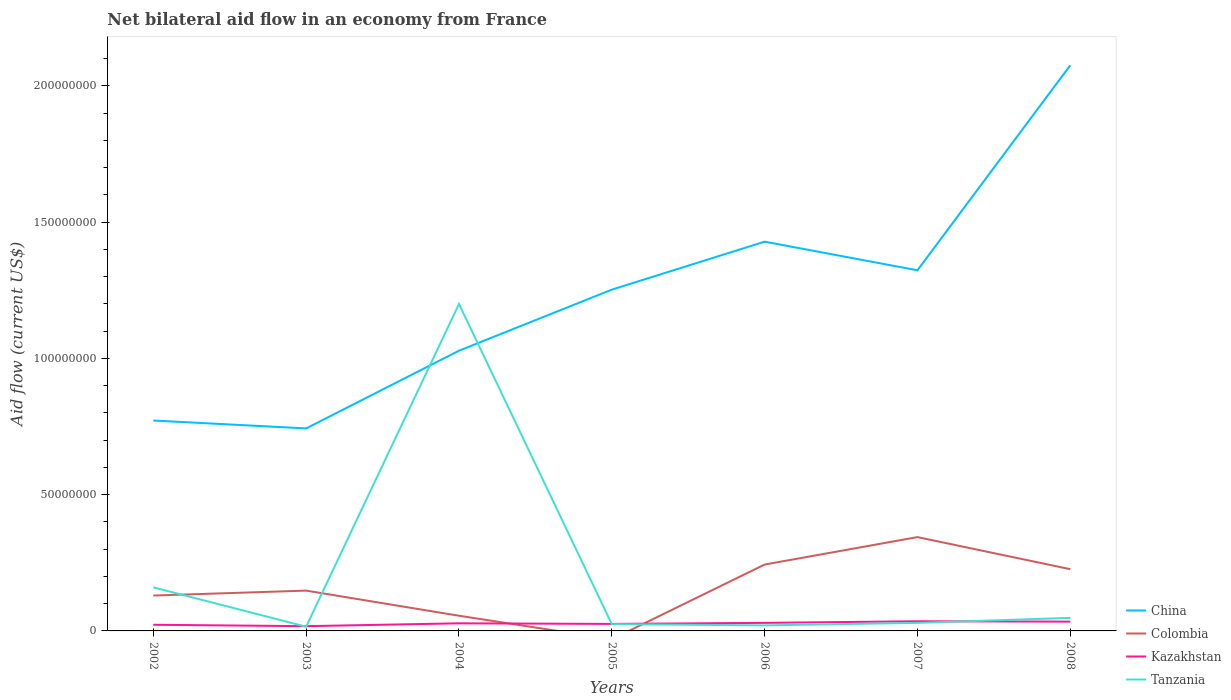How many different coloured lines are there?
Make the answer very short. 4. Does the line corresponding to Colombia intersect with the line corresponding to Tanzania?
Provide a succinct answer. Yes. Is the number of lines equal to the number of legend labels?
Your response must be concise. No. Across all years, what is the maximum net bilateral aid flow in Colombia?
Offer a very short reply. 0. What is the total net bilateral aid flow in Colombia in the graph?
Your response must be concise. 1.18e+07. What is the difference between the highest and the second highest net bilateral aid flow in Tanzania?
Make the answer very short. 1.18e+08. What is the difference between the highest and the lowest net bilateral aid flow in Tanzania?
Provide a short and direct response. 1. What is the title of the graph?
Provide a succinct answer. Net bilateral aid flow in an economy from France. Does "Guinea-Bissau" appear as one of the legend labels in the graph?
Give a very brief answer. No. What is the Aid flow (current US$) in China in 2002?
Make the answer very short. 7.72e+07. What is the Aid flow (current US$) of Colombia in 2002?
Your answer should be very brief. 1.30e+07. What is the Aid flow (current US$) of Kazakhstan in 2002?
Your answer should be very brief. 2.26e+06. What is the Aid flow (current US$) in Tanzania in 2002?
Give a very brief answer. 1.60e+07. What is the Aid flow (current US$) of China in 2003?
Ensure brevity in your answer.  7.43e+07. What is the Aid flow (current US$) in Colombia in 2003?
Provide a succinct answer. 1.48e+07. What is the Aid flow (current US$) in Kazakhstan in 2003?
Provide a short and direct response. 1.74e+06. What is the Aid flow (current US$) in Tanzania in 2003?
Your answer should be very brief. 1.55e+06. What is the Aid flow (current US$) of China in 2004?
Provide a short and direct response. 1.03e+08. What is the Aid flow (current US$) of Colombia in 2004?
Keep it short and to the point. 5.57e+06. What is the Aid flow (current US$) in Kazakhstan in 2004?
Keep it short and to the point. 2.79e+06. What is the Aid flow (current US$) in Tanzania in 2004?
Make the answer very short. 1.20e+08. What is the Aid flow (current US$) of China in 2005?
Provide a short and direct response. 1.25e+08. What is the Aid flow (current US$) of Colombia in 2005?
Keep it short and to the point. 0. What is the Aid flow (current US$) of Kazakhstan in 2005?
Your answer should be very brief. 2.57e+06. What is the Aid flow (current US$) of Tanzania in 2005?
Keep it short and to the point. 2.48e+06. What is the Aid flow (current US$) of China in 2006?
Offer a terse response. 1.43e+08. What is the Aid flow (current US$) of Colombia in 2006?
Ensure brevity in your answer.  2.44e+07. What is the Aid flow (current US$) of Kazakhstan in 2006?
Provide a short and direct response. 2.96e+06. What is the Aid flow (current US$) in Tanzania in 2006?
Provide a short and direct response. 2.03e+06. What is the Aid flow (current US$) in China in 2007?
Your answer should be very brief. 1.32e+08. What is the Aid flow (current US$) in Colombia in 2007?
Make the answer very short. 3.44e+07. What is the Aid flow (current US$) of Kazakhstan in 2007?
Your answer should be compact. 3.54e+06. What is the Aid flow (current US$) of Tanzania in 2007?
Offer a very short reply. 2.96e+06. What is the Aid flow (current US$) of China in 2008?
Provide a succinct answer. 2.08e+08. What is the Aid flow (current US$) in Colombia in 2008?
Keep it short and to the point. 2.26e+07. What is the Aid flow (current US$) in Kazakhstan in 2008?
Give a very brief answer. 3.41e+06. What is the Aid flow (current US$) of Tanzania in 2008?
Ensure brevity in your answer.  4.78e+06. Across all years, what is the maximum Aid flow (current US$) of China?
Provide a succinct answer. 2.08e+08. Across all years, what is the maximum Aid flow (current US$) in Colombia?
Ensure brevity in your answer.  3.44e+07. Across all years, what is the maximum Aid flow (current US$) of Kazakhstan?
Make the answer very short. 3.54e+06. Across all years, what is the maximum Aid flow (current US$) of Tanzania?
Provide a short and direct response. 1.20e+08. Across all years, what is the minimum Aid flow (current US$) in China?
Provide a short and direct response. 7.43e+07. Across all years, what is the minimum Aid flow (current US$) in Colombia?
Your response must be concise. 0. Across all years, what is the minimum Aid flow (current US$) of Kazakhstan?
Provide a short and direct response. 1.74e+06. Across all years, what is the minimum Aid flow (current US$) in Tanzania?
Offer a terse response. 1.55e+06. What is the total Aid flow (current US$) in China in the graph?
Keep it short and to the point. 8.62e+08. What is the total Aid flow (current US$) of Colombia in the graph?
Your answer should be very brief. 1.15e+08. What is the total Aid flow (current US$) of Kazakhstan in the graph?
Offer a terse response. 1.93e+07. What is the total Aid flow (current US$) in Tanzania in the graph?
Your answer should be compact. 1.50e+08. What is the difference between the Aid flow (current US$) in China in 2002 and that in 2003?
Provide a succinct answer. 2.90e+06. What is the difference between the Aid flow (current US$) in Colombia in 2002 and that in 2003?
Make the answer very short. -1.81e+06. What is the difference between the Aid flow (current US$) of Kazakhstan in 2002 and that in 2003?
Keep it short and to the point. 5.20e+05. What is the difference between the Aid flow (current US$) of Tanzania in 2002 and that in 2003?
Offer a very short reply. 1.44e+07. What is the difference between the Aid flow (current US$) of China in 2002 and that in 2004?
Give a very brief answer. -2.56e+07. What is the difference between the Aid flow (current US$) of Colombia in 2002 and that in 2004?
Provide a succinct answer. 7.41e+06. What is the difference between the Aid flow (current US$) of Kazakhstan in 2002 and that in 2004?
Ensure brevity in your answer.  -5.30e+05. What is the difference between the Aid flow (current US$) in Tanzania in 2002 and that in 2004?
Keep it short and to the point. -1.04e+08. What is the difference between the Aid flow (current US$) in China in 2002 and that in 2005?
Your answer should be compact. -4.80e+07. What is the difference between the Aid flow (current US$) in Kazakhstan in 2002 and that in 2005?
Make the answer very short. -3.10e+05. What is the difference between the Aid flow (current US$) of Tanzania in 2002 and that in 2005?
Provide a succinct answer. 1.35e+07. What is the difference between the Aid flow (current US$) of China in 2002 and that in 2006?
Keep it short and to the point. -6.56e+07. What is the difference between the Aid flow (current US$) of Colombia in 2002 and that in 2006?
Your response must be concise. -1.14e+07. What is the difference between the Aid flow (current US$) in Kazakhstan in 2002 and that in 2006?
Offer a very short reply. -7.00e+05. What is the difference between the Aid flow (current US$) in Tanzania in 2002 and that in 2006?
Make the answer very short. 1.40e+07. What is the difference between the Aid flow (current US$) in China in 2002 and that in 2007?
Your answer should be very brief. -5.51e+07. What is the difference between the Aid flow (current US$) of Colombia in 2002 and that in 2007?
Ensure brevity in your answer.  -2.14e+07. What is the difference between the Aid flow (current US$) of Kazakhstan in 2002 and that in 2007?
Provide a succinct answer. -1.28e+06. What is the difference between the Aid flow (current US$) of Tanzania in 2002 and that in 2007?
Offer a very short reply. 1.30e+07. What is the difference between the Aid flow (current US$) in China in 2002 and that in 2008?
Provide a succinct answer. -1.30e+08. What is the difference between the Aid flow (current US$) in Colombia in 2002 and that in 2008?
Make the answer very short. -9.67e+06. What is the difference between the Aid flow (current US$) of Kazakhstan in 2002 and that in 2008?
Provide a succinct answer. -1.15e+06. What is the difference between the Aid flow (current US$) in Tanzania in 2002 and that in 2008?
Offer a very short reply. 1.12e+07. What is the difference between the Aid flow (current US$) in China in 2003 and that in 2004?
Offer a very short reply. -2.85e+07. What is the difference between the Aid flow (current US$) in Colombia in 2003 and that in 2004?
Provide a short and direct response. 9.22e+06. What is the difference between the Aid flow (current US$) in Kazakhstan in 2003 and that in 2004?
Your response must be concise. -1.05e+06. What is the difference between the Aid flow (current US$) in Tanzania in 2003 and that in 2004?
Make the answer very short. -1.18e+08. What is the difference between the Aid flow (current US$) of China in 2003 and that in 2005?
Your response must be concise. -5.09e+07. What is the difference between the Aid flow (current US$) in Kazakhstan in 2003 and that in 2005?
Provide a succinct answer. -8.30e+05. What is the difference between the Aid flow (current US$) of Tanzania in 2003 and that in 2005?
Make the answer very short. -9.30e+05. What is the difference between the Aid flow (current US$) in China in 2003 and that in 2006?
Make the answer very short. -6.85e+07. What is the difference between the Aid flow (current US$) in Colombia in 2003 and that in 2006?
Your answer should be compact. -9.56e+06. What is the difference between the Aid flow (current US$) in Kazakhstan in 2003 and that in 2006?
Your answer should be compact. -1.22e+06. What is the difference between the Aid flow (current US$) of Tanzania in 2003 and that in 2006?
Make the answer very short. -4.80e+05. What is the difference between the Aid flow (current US$) of China in 2003 and that in 2007?
Make the answer very short. -5.80e+07. What is the difference between the Aid flow (current US$) in Colombia in 2003 and that in 2007?
Offer a very short reply. -1.96e+07. What is the difference between the Aid flow (current US$) of Kazakhstan in 2003 and that in 2007?
Ensure brevity in your answer.  -1.80e+06. What is the difference between the Aid flow (current US$) of Tanzania in 2003 and that in 2007?
Make the answer very short. -1.41e+06. What is the difference between the Aid flow (current US$) in China in 2003 and that in 2008?
Offer a very short reply. -1.33e+08. What is the difference between the Aid flow (current US$) of Colombia in 2003 and that in 2008?
Your response must be concise. -7.86e+06. What is the difference between the Aid flow (current US$) of Kazakhstan in 2003 and that in 2008?
Offer a terse response. -1.67e+06. What is the difference between the Aid flow (current US$) in Tanzania in 2003 and that in 2008?
Your answer should be very brief. -3.23e+06. What is the difference between the Aid flow (current US$) in China in 2004 and that in 2005?
Make the answer very short. -2.24e+07. What is the difference between the Aid flow (current US$) in Tanzania in 2004 and that in 2005?
Offer a very short reply. 1.17e+08. What is the difference between the Aid flow (current US$) in China in 2004 and that in 2006?
Give a very brief answer. -4.00e+07. What is the difference between the Aid flow (current US$) in Colombia in 2004 and that in 2006?
Ensure brevity in your answer.  -1.88e+07. What is the difference between the Aid flow (current US$) of Tanzania in 2004 and that in 2006?
Your response must be concise. 1.18e+08. What is the difference between the Aid flow (current US$) in China in 2004 and that in 2007?
Keep it short and to the point. -2.95e+07. What is the difference between the Aid flow (current US$) of Colombia in 2004 and that in 2007?
Provide a short and direct response. -2.88e+07. What is the difference between the Aid flow (current US$) in Kazakhstan in 2004 and that in 2007?
Keep it short and to the point. -7.50e+05. What is the difference between the Aid flow (current US$) of Tanzania in 2004 and that in 2007?
Offer a very short reply. 1.17e+08. What is the difference between the Aid flow (current US$) in China in 2004 and that in 2008?
Make the answer very short. -1.05e+08. What is the difference between the Aid flow (current US$) of Colombia in 2004 and that in 2008?
Keep it short and to the point. -1.71e+07. What is the difference between the Aid flow (current US$) in Kazakhstan in 2004 and that in 2008?
Your answer should be very brief. -6.20e+05. What is the difference between the Aid flow (current US$) of Tanzania in 2004 and that in 2008?
Give a very brief answer. 1.15e+08. What is the difference between the Aid flow (current US$) of China in 2005 and that in 2006?
Your answer should be very brief. -1.76e+07. What is the difference between the Aid flow (current US$) in Kazakhstan in 2005 and that in 2006?
Give a very brief answer. -3.90e+05. What is the difference between the Aid flow (current US$) of China in 2005 and that in 2007?
Offer a terse response. -7.10e+06. What is the difference between the Aid flow (current US$) of Kazakhstan in 2005 and that in 2007?
Provide a short and direct response. -9.70e+05. What is the difference between the Aid flow (current US$) in Tanzania in 2005 and that in 2007?
Your answer should be very brief. -4.80e+05. What is the difference between the Aid flow (current US$) in China in 2005 and that in 2008?
Offer a very short reply. -8.23e+07. What is the difference between the Aid flow (current US$) in Kazakhstan in 2005 and that in 2008?
Your response must be concise. -8.40e+05. What is the difference between the Aid flow (current US$) of Tanzania in 2005 and that in 2008?
Your answer should be very brief. -2.30e+06. What is the difference between the Aid flow (current US$) of China in 2006 and that in 2007?
Offer a terse response. 1.05e+07. What is the difference between the Aid flow (current US$) of Colombia in 2006 and that in 2007?
Make the answer very short. -1.01e+07. What is the difference between the Aid flow (current US$) of Kazakhstan in 2006 and that in 2007?
Your answer should be very brief. -5.80e+05. What is the difference between the Aid flow (current US$) of Tanzania in 2006 and that in 2007?
Your answer should be very brief. -9.30e+05. What is the difference between the Aid flow (current US$) of China in 2006 and that in 2008?
Your answer should be compact. -6.47e+07. What is the difference between the Aid flow (current US$) of Colombia in 2006 and that in 2008?
Ensure brevity in your answer.  1.70e+06. What is the difference between the Aid flow (current US$) in Kazakhstan in 2006 and that in 2008?
Your response must be concise. -4.50e+05. What is the difference between the Aid flow (current US$) of Tanzania in 2006 and that in 2008?
Your answer should be compact. -2.75e+06. What is the difference between the Aid flow (current US$) in China in 2007 and that in 2008?
Keep it short and to the point. -7.52e+07. What is the difference between the Aid flow (current US$) in Colombia in 2007 and that in 2008?
Offer a terse response. 1.18e+07. What is the difference between the Aid flow (current US$) of Kazakhstan in 2007 and that in 2008?
Offer a terse response. 1.30e+05. What is the difference between the Aid flow (current US$) in Tanzania in 2007 and that in 2008?
Provide a short and direct response. -1.82e+06. What is the difference between the Aid flow (current US$) in China in 2002 and the Aid flow (current US$) in Colombia in 2003?
Ensure brevity in your answer.  6.24e+07. What is the difference between the Aid flow (current US$) of China in 2002 and the Aid flow (current US$) of Kazakhstan in 2003?
Keep it short and to the point. 7.54e+07. What is the difference between the Aid flow (current US$) in China in 2002 and the Aid flow (current US$) in Tanzania in 2003?
Offer a terse response. 7.56e+07. What is the difference between the Aid flow (current US$) of Colombia in 2002 and the Aid flow (current US$) of Kazakhstan in 2003?
Give a very brief answer. 1.12e+07. What is the difference between the Aid flow (current US$) of Colombia in 2002 and the Aid flow (current US$) of Tanzania in 2003?
Offer a very short reply. 1.14e+07. What is the difference between the Aid flow (current US$) in Kazakhstan in 2002 and the Aid flow (current US$) in Tanzania in 2003?
Your answer should be compact. 7.10e+05. What is the difference between the Aid flow (current US$) in China in 2002 and the Aid flow (current US$) in Colombia in 2004?
Give a very brief answer. 7.16e+07. What is the difference between the Aid flow (current US$) of China in 2002 and the Aid flow (current US$) of Kazakhstan in 2004?
Your answer should be very brief. 7.44e+07. What is the difference between the Aid flow (current US$) of China in 2002 and the Aid flow (current US$) of Tanzania in 2004?
Provide a succinct answer. -4.28e+07. What is the difference between the Aid flow (current US$) of Colombia in 2002 and the Aid flow (current US$) of Kazakhstan in 2004?
Your response must be concise. 1.02e+07. What is the difference between the Aid flow (current US$) in Colombia in 2002 and the Aid flow (current US$) in Tanzania in 2004?
Ensure brevity in your answer.  -1.07e+08. What is the difference between the Aid flow (current US$) of Kazakhstan in 2002 and the Aid flow (current US$) of Tanzania in 2004?
Ensure brevity in your answer.  -1.18e+08. What is the difference between the Aid flow (current US$) of China in 2002 and the Aid flow (current US$) of Kazakhstan in 2005?
Give a very brief answer. 7.46e+07. What is the difference between the Aid flow (current US$) of China in 2002 and the Aid flow (current US$) of Tanzania in 2005?
Give a very brief answer. 7.47e+07. What is the difference between the Aid flow (current US$) in Colombia in 2002 and the Aid flow (current US$) in Kazakhstan in 2005?
Ensure brevity in your answer.  1.04e+07. What is the difference between the Aid flow (current US$) in Colombia in 2002 and the Aid flow (current US$) in Tanzania in 2005?
Provide a succinct answer. 1.05e+07. What is the difference between the Aid flow (current US$) in China in 2002 and the Aid flow (current US$) in Colombia in 2006?
Your response must be concise. 5.28e+07. What is the difference between the Aid flow (current US$) in China in 2002 and the Aid flow (current US$) in Kazakhstan in 2006?
Your response must be concise. 7.42e+07. What is the difference between the Aid flow (current US$) of China in 2002 and the Aid flow (current US$) of Tanzania in 2006?
Give a very brief answer. 7.52e+07. What is the difference between the Aid flow (current US$) of Colombia in 2002 and the Aid flow (current US$) of Kazakhstan in 2006?
Keep it short and to the point. 1.00e+07. What is the difference between the Aid flow (current US$) of Colombia in 2002 and the Aid flow (current US$) of Tanzania in 2006?
Give a very brief answer. 1.10e+07. What is the difference between the Aid flow (current US$) in China in 2002 and the Aid flow (current US$) in Colombia in 2007?
Your answer should be very brief. 4.28e+07. What is the difference between the Aid flow (current US$) in China in 2002 and the Aid flow (current US$) in Kazakhstan in 2007?
Ensure brevity in your answer.  7.36e+07. What is the difference between the Aid flow (current US$) in China in 2002 and the Aid flow (current US$) in Tanzania in 2007?
Offer a terse response. 7.42e+07. What is the difference between the Aid flow (current US$) of Colombia in 2002 and the Aid flow (current US$) of Kazakhstan in 2007?
Offer a very short reply. 9.44e+06. What is the difference between the Aid flow (current US$) in Colombia in 2002 and the Aid flow (current US$) in Tanzania in 2007?
Make the answer very short. 1.00e+07. What is the difference between the Aid flow (current US$) in Kazakhstan in 2002 and the Aid flow (current US$) in Tanzania in 2007?
Make the answer very short. -7.00e+05. What is the difference between the Aid flow (current US$) in China in 2002 and the Aid flow (current US$) in Colombia in 2008?
Make the answer very short. 5.45e+07. What is the difference between the Aid flow (current US$) of China in 2002 and the Aid flow (current US$) of Kazakhstan in 2008?
Provide a short and direct response. 7.38e+07. What is the difference between the Aid flow (current US$) of China in 2002 and the Aid flow (current US$) of Tanzania in 2008?
Your response must be concise. 7.24e+07. What is the difference between the Aid flow (current US$) of Colombia in 2002 and the Aid flow (current US$) of Kazakhstan in 2008?
Make the answer very short. 9.57e+06. What is the difference between the Aid flow (current US$) of Colombia in 2002 and the Aid flow (current US$) of Tanzania in 2008?
Give a very brief answer. 8.20e+06. What is the difference between the Aid flow (current US$) of Kazakhstan in 2002 and the Aid flow (current US$) of Tanzania in 2008?
Give a very brief answer. -2.52e+06. What is the difference between the Aid flow (current US$) in China in 2003 and the Aid flow (current US$) in Colombia in 2004?
Ensure brevity in your answer.  6.87e+07. What is the difference between the Aid flow (current US$) in China in 2003 and the Aid flow (current US$) in Kazakhstan in 2004?
Provide a succinct answer. 7.15e+07. What is the difference between the Aid flow (current US$) of China in 2003 and the Aid flow (current US$) of Tanzania in 2004?
Give a very brief answer. -4.57e+07. What is the difference between the Aid flow (current US$) of Colombia in 2003 and the Aid flow (current US$) of Tanzania in 2004?
Give a very brief answer. -1.05e+08. What is the difference between the Aid flow (current US$) in Kazakhstan in 2003 and the Aid flow (current US$) in Tanzania in 2004?
Offer a very short reply. -1.18e+08. What is the difference between the Aid flow (current US$) in China in 2003 and the Aid flow (current US$) in Kazakhstan in 2005?
Ensure brevity in your answer.  7.17e+07. What is the difference between the Aid flow (current US$) of China in 2003 and the Aid flow (current US$) of Tanzania in 2005?
Provide a succinct answer. 7.18e+07. What is the difference between the Aid flow (current US$) of Colombia in 2003 and the Aid flow (current US$) of Kazakhstan in 2005?
Offer a very short reply. 1.22e+07. What is the difference between the Aid flow (current US$) in Colombia in 2003 and the Aid flow (current US$) in Tanzania in 2005?
Your response must be concise. 1.23e+07. What is the difference between the Aid flow (current US$) of Kazakhstan in 2003 and the Aid flow (current US$) of Tanzania in 2005?
Your answer should be compact. -7.40e+05. What is the difference between the Aid flow (current US$) in China in 2003 and the Aid flow (current US$) in Colombia in 2006?
Your response must be concise. 4.99e+07. What is the difference between the Aid flow (current US$) of China in 2003 and the Aid flow (current US$) of Kazakhstan in 2006?
Provide a short and direct response. 7.13e+07. What is the difference between the Aid flow (current US$) of China in 2003 and the Aid flow (current US$) of Tanzania in 2006?
Ensure brevity in your answer.  7.23e+07. What is the difference between the Aid flow (current US$) of Colombia in 2003 and the Aid flow (current US$) of Kazakhstan in 2006?
Make the answer very short. 1.18e+07. What is the difference between the Aid flow (current US$) of Colombia in 2003 and the Aid flow (current US$) of Tanzania in 2006?
Ensure brevity in your answer.  1.28e+07. What is the difference between the Aid flow (current US$) in Kazakhstan in 2003 and the Aid flow (current US$) in Tanzania in 2006?
Offer a terse response. -2.90e+05. What is the difference between the Aid flow (current US$) in China in 2003 and the Aid flow (current US$) in Colombia in 2007?
Ensure brevity in your answer.  3.99e+07. What is the difference between the Aid flow (current US$) in China in 2003 and the Aid flow (current US$) in Kazakhstan in 2007?
Offer a terse response. 7.08e+07. What is the difference between the Aid flow (current US$) in China in 2003 and the Aid flow (current US$) in Tanzania in 2007?
Make the answer very short. 7.13e+07. What is the difference between the Aid flow (current US$) of Colombia in 2003 and the Aid flow (current US$) of Kazakhstan in 2007?
Keep it short and to the point. 1.12e+07. What is the difference between the Aid flow (current US$) in Colombia in 2003 and the Aid flow (current US$) in Tanzania in 2007?
Make the answer very short. 1.18e+07. What is the difference between the Aid flow (current US$) of Kazakhstan in 2003 and the Aid flow (current US$) of Tanzania in 2007?
Give a very brief answer. -1.22e+06. What is the difference between the Aid flow (current US$) of China in 2003 and the Aid flow (current US$) of Colombia in 2008?
Provide a short and direct response. 5.16e+07. What is the difference between the Aid flow (current US$) in China in 2003 and the Aid flow (current US$) in Kazakhstan in 2008?
Your answer should be compact. 7.09e+07. What is the difference between the Aid flow (current US$) of China in 2003 and the Aid flow (current US$) of Tanzania in 2008?
Offer a terse response. 6.95e+07. What is the difference between the Aid flow (current US$) in Colombia in 2003 and the Aid flow (current US$) in Kazakhstan in 2008?
Ensure brevity in your answer.  1.14e+07. What is the difference between the Aid flow (current US$) in Colombia in 2003 and the Aid flow (current US$) in Tanzania in 2008?
Make the answer very short. 1.00e+07. What is the difference between the Aid flow (current US$) of Kazakhstan in 2003 and the Aid flow (current US$) of Tanzania in 2008?
Offer a terse response. -3.04e+06. What is the difference between the Aid flow (current US$) in China in 2004 and the Aid flow (current US$) in Kazakhstan in 2005?
Your response must be concise. 1.00e+08. What is the difference between the Aid flow (current US$) in China in 2004 and the Aid flow (current US$) in Tanzania in 2005?
Ensure brevity in your answer.  1.00e+08. What is the difference between the Aid flow (current US$) in Colombia in 2004 and the Aid flow (current US$) in Kazakhstan in 2005?
Make the answer very short. 3.00e+06. What is the difference between the Aid flow (current US$) in Colombia in 2004 and the Aid flow (current US$) in Tanzania in 2005?
Provide a short and direct response. 3.09e+06. What is the difference between the Aid flow (current US$) in China in 2004 and the Aid flow (current US$) in Colombia in 2006?
Offer a terse response. 7.84e+07. What is the difference between the Aid flow (current US$) of China in 2004 and the Aid flow (current US$) of Kazakhstan in 2006?
Your answer should be very brief. 9.98e+07. What is the difference between the Aid flow (current US$) of China in 2004 and the Aid flow (current US$) of Tanzania in 2006?
Provide a short and direct response. 1.01e+08. What is the difference between the Aid flow (current US$) in Colombia in 2004 and the Aid flow (current US$) in Kazakhstan in 2006?
Your answer should be very brief. 2.61e+06. What is the difference between the Aid flow (current US$) in Colombia in 2004 and the Aid flow (current US$) in Tanzania in 2006?
Ensure brevity in your answer.  3.54e+06. What is the difference between the Aid flow (current US$) of Kazakhstan in 2004 and the Aid flow (current US$) of Tanzania in 2006?
Make the answer very short. 7.60e+05. What is the difference between the Aid flow (current US$) of China in 2004 and the Aid flow (current US$) of Colombia in 2007?
Provide a short and direct response. 6.84e+07. What is the difference between the Aid flow (current US$) in China in 2004 and the Aid flow (current US$) in Kazakhstan in 2007?
Your response must be concise. 9.93e+07. What is the difference between the Aid flow (current US$) in China in 2004 and the Aid flow (current US$) in Tanzania in 2007?
Give a very brief answer. 9.98e+07. What is the difference between the Aid flow (current US$) of Colombia in 2004 and the Aid flow (current US$) of Kazakhstan in 2007?
Offer a terse response. 2.03e+06. What is the difference between the Aid flow (current US$) of Colombia in 2004 and the Aid flow (current US$) of Tanzania in 2007?
Your response must be concise. 2.61e+06. What is the difference between the Aid flow (current US$) in China in 2004 and the Aid flow (current US$) in Colombia in 2008?
Offer a very short reply. 8.02e+07. What is the difference between the Aid flow (current US$) of China in 2004 and the Aid flow (current US$) of Kazakhstan in 2008?
Your response must be concise. 9.94e+07. What is the difference between the Aid flow (current US$) in China in 2004 and the Aid flow (current US$) in Tanzania in 2008?
Provide a short and direct response. 9.80e+07. What is the difference between the Aid flow (current US$) of Colombia in 2004 and the Aid flow (current US$) of Kazakhstan in 2008?
Ensure brevity in your answer.  2.16e+06. What is the difference between the Aid flow (current US$) in Colombia in 2004 and the Aid flow (current US$) in Tanzania in 2008?
Your answer should be compact. 7.90e+05. What is the difference between the Aid flow (current US$) of Kazakhstan in 2004 and the Aid flow (current US$) of Tanzania in 2008?
Your answer should be very brief. -1.99e+06. What is the difference between the Aid flow (current US$) of China in 2005 and the Aid flow (current US$) of Colombia in 2006?
Your answer should be very brief. 1.01e+08. What is the difference between the Aid flow (current US$) in China in 2005 and the Aid flow (current US$) in Kazakhstan in 2006?
Make the answer very short. 1.22e+08. What is the difference between the Aid flow (current US$) of China in 2005 and the Aid flow (current US$) of Tanzania in 2006?
Keep it short and to the point. 1.23e+08. What is the difference between the Aid flow (current US$) in Kazakhstan in 2005 and the Aid flow (current US$) in Tanzania in 2006?
Provide a succinct answer. 5.40e+05. What is the difference between the Aid flow (current US$) in China in 2005 and the Aid flow (current US$) in Colombia in 2007?
Make the answer very short. 9.08e+07. What is the difference between the Aid flow (current US$) in China in 2005 and the Aid flow (current US$) in Kazakhstan in 2007?
Provide a succinct answer. 1.22e+08. What is the difference between the Aid flow (current US$) of China in 2005 and the Aid flow (current US$) of Tanzania in 2007?
Make the answer very short. 1.22e+08. What is the difference between the Aid flow (current US$) of Kazakhstan in 2005 and the Aid flow (current US$) of Tanzania in 2007?
Make the answer very short. -3.90e+05. What is the difference between the Aid flow (current US$) in China in 2005 and the Aid flow (current US$) in Colombia in 2008?
Your response must be concise. 1.03e+08. What is the difference between the Aid flow (current US$) of China in 2005 and the Aid flow (current US$) of Kazakhstan in 2008?
Offer a very short reply. 1.22e+08. What is the difference between the Aid flow (current US$) of China in 2005 and the Aid flow (current US$) of Tanzania in 2008?
Provide a short and direct response. 1.20e+08. What is the difference between the Aid flow (current US$) in Kazakhstan in 2005 and the Aid flow (current US$) in Tanzania in 2008?
Offer a terse response. -2.21e+06. What is the difference between the Aid flow (current US$) in China in 2006 and the Aid flow (current US$) in Colombia in 2007?
Give a very brief answer. 1.08e+08. What is the difference between the Aid flow (current US$) of China in 2006 and the Aid flow (current US$) of Kazakhstan in 2007?
Keep it short and to the point. 1.39e+08. What is the difference between the Aid flow (current US$) of China in 2006 and the Aid flow (current US$) of Tanzania in 2007?
Your answer should be compact. 1.40e+08. What is the difference between the Aid flow (current US$) of Colombia in 2006 and the Aid flow (current US$) of Kazakhstan in 2007?
Keep it short and to the point. 2.08e+07. What is the difference between the Aid flow (current US$) of Colombia in 2006 and the Aid flow (current US$) of Tanzania in 2007?
Your response must be concise. 2.14e+07. What is the difference between the Aid flow (current US$) of China in 2006 and the Aid flow (current US$) of Colombia in 2008?
Offer a very short reply. 1.20e+08. What is the difference between the Aid flow (current US$) of China in 2006 and the Aid flow (current US$) of Kazakhstan in 2008?
Keep it short and to the point. 1.39e+08. What is the difference between the Aid flow (current US$) in China in 2006 and the Aid flow (current US$) in Tanzania in 2008?
Keep it short and to the point. 1.38e+08. What is the difference between the Aid flow (current US$) in Colombia in 2006 and the Aid flow (current US$) in Kazakhstan in 2008?
Make the answer very short. 2.09e+07. What is the difference between the Aid flow (current US$) of Colombia in 2006 and the Aid flow (current US$) of Tanzania in 2008?
Offer a very short reply. 1.96e+07. What is the difference between the Aid flow (current US$) of Kazakhstan in 2006 and the Aid flow (current US$) of Tanzania in 2008?
Your answer should be very brief. -1.82e+06. What is the difference between the Aid flow (current US$) of China in 2007 and the Aid flow (current US$) of Colombia in 2008?
Provide a short and direct response. 1.10e+08. What is the difference between the Aid flow (current US$) of China in 2007 and the Aid flow (current US$) of Kazakhstan in 2008?
Provide a short and direct response. 1.29e+08. What is the difference between the Aid flow (current US$) in China in 2007 and the Aid flow (current US$) in Tanzania in 2008?
Give a very brief answer. 1.28e+08. What is the difference between the Aid flow (current US$) in Colombia in 2007 and the Aid flow (current US$) in Kazakhstan in 2008?
Your answer should be compact. 3.10e+07. What is the difference between the Aid flow (current US$) in Colombia in 2007 and the Aid flow (current US$) in Tanzania in 2008?
Offer a terse response. 2.96e+07. What is the difference between the Aid flow (current US$) of Kazakhstan in 2007 and the Aid flow (current US$) of Tanzania in 2008?
Offer a terse response. -1.24e+06. What is the average Aid flow (current US$) in China per year?
Make the answer very short. 1.23e+08. What is the average Aid flow (current US$) in Colombia per year?
Offer a terse response. 1.64e+07. What is the average Aid flow (current US$) in Kazakhstan per year?
Provide a short and direct response. 2.75e+06. What is the average Aid flow (current US$) in Tanzania per year?
Your response must be concise. 2.14e+07. In the year 2002, what is the difference between the Aid flow (current US$) in China and Aid flow (current US$) in Colombia?
Ensure brevity in your answer.  6.42e+07. In the year 2002, what is the difference between the Aid flow (current US$) of China and Aid flow (current US$) of Kazakhstan?
Your response must be concise. 7.49e+07. In the year 2002, what is the difference between the Aid flow (current US$) of China and Aid flow (current US$) of Tanzania?
Provide a succinct answer. 6.12e+07. In the year 2002, what is the difference between the Aid flow (current US$) in Colombia and Aid flow (current US$) in Kazakhstan?
Give a very brief answer. 1.07e+07. In the year 2002, what is the difference between the Aid flow (current US$) in Colombia and Aid flow (current US$) in Tanzania?
Your response must be concise. -3.00e+06. In the year 2002, what is the difference between the Aid flow (current US$) of Kazakhstan and Aid flow (current US$) of Tanzania?
Make the answer very short. -1.37e+07. In the year 2003, what is the difference between the Aid flow (current US$) in China and Aid flow (current US$) in Colombia?
Provide a short and direct response. 5.95e+07. In the year 2003, what is the difference between the Aid flow (current US$) in China and Aid flow (current US$) in Kazakhstan?
Your response must be concise. 7.26e+07. In the year 2003, what is the difference between the Aid flow (current US$) of China and Aid flow (current US$) of Tanzania?
Your answer should be compact. 7.27e+07. In the year 2003, what is the difference between the Aid flow (current US$) in Colombia and Aid flow (current US$) in Kazakhstan?
Make the answer very short. 1.30e+07. In the year 2003, what is the difference between the Aid flow (current US$) of Colombia and Aid flow (current US$) of Tanzania?
Offer a very short reply. 1.32e+07. In the year 2004, what is the difference between the Aid flow (current US$) in China and Aid flow (current US$) in Colombia?
Make the answer very short. 9.72e+07. In the year 2004, what is the difference between the Aid flow (current US$) in China and Aid flow (current US$) in Kazakhstan?
Offer a very short reply. 1.00e+08. In the year 2004, what is the difference between the Aid flow (current US$) of China and Aid flow (current US$) of Tanzania?
Your response must be concise. -1.72e+07. In the year 2004, what is the difference between the Aid flow (current US$) in Colombia and Aid flow (current US$) in Kazakhstan?
Make the answer very short. 2.78e+06. In the year 2004, what is the difference between the Aid flow (current US$) in Colombia and Aid flow (current US$) in Tanzania?
Make the answer very short. -1.14e+08. In the year 2004, what is the difference between the Aid flow (current US$) in Kazakhstan and Aid flow (current US$) in Tanzania?
Your answer should be very brief. -1.17e+08. In the year 2005, what is the difference between the Aid flow (current US$) of China and Aid flow (current US$) of Kazakhstan?
Make the answer very short. 1.23e+08. In the year 2005, what is the difference between the Aid flow (current US$) in China and Aid flow (current US$) in Tanzania?
Give a very brief answer. 1.23e+08. In the year 2006, what is the difference between the Aid flow (current US$) of China and Aid flow (current US$) of Colombia?
Make the answer very short. 1.18e+08. In the year 2006, what is the difference between the Aid flow (current US$) of China and Aid flow (current US$) of Kazakhstan?
Keep it short and to the point. 1.40e+08. In the year 2006, what is the difference between the Aid flow (current US$) of China and Aid flow (current US$) of Tanzania?
Your response must be concise. 1.41e+08. In the year 2006, what is the difference between the Aid flow (current US$) in Colombia and Aid flow (current US$) in Kazakhstan?
Provide a short and direct response. 2.14e+07. In the year 2006, what is the difference between the Aid flow (current US$) in Colombia and Aid flow (current US$) in Tanzania?
Give a very brief answer. 2.23e+07. In the year 2006, what is the difference between the Aid flow (current US$) in Kazakhstan and Aid flow (current US$) in Tanzania?
Offer a terse response. 9.30e+05. In the year 2007, what is the difference between the Aid flow (current US$) of China and Aid flow (current US$) of Colombia?
Offer a very short reply. 9.79e+07. In the year 2007, what is the difference between the Aid flow (current US$) of China and Aid flow (current US$) of Kazakhstan?
Give a very brief answer. 1.29e+08. In the year 2007, what is the difference between the Aid flow (current US$) in China and Aid flow (current US$) in Tanzania?
Ensure brevity in your answer.  1.29e+08. In the year 2007, what is the difference between the Aid flow (current US$) in Colombia and Aid flow (current US$) in Kazakhstan?
Your answer should be compact. 3.09e+07. In the year 2007, what is the difference between the Aid flow (current US$) in Colombia and Aid flow (current US$) in Tanzania?
Your response must be concise. 3.15e+07. In the year 2007, what is the difference between the Aid flow (current US$) in Kazakhstan and Aid flow (current US$) in Tanzania?
Your answer should be very brief. 5.80e+05. In the year 2008, what is the difference between the Aid flow (current US$) of China and Aid flow (current US$) of Colombia?
Make the answer very short. 1.85e+08. In the year 2008, what is the difference between the Aid flow (current US$) of China and Aid flow (current US$) of Kazakhstan?
Offer a very short reply. 2.04e+08. In the year 2008, what is the difference between the Aid flow (current US$) in China and Aid flow (current US$) in Tanzania?
Your answer should be compact. 2.03e+08. In the year 2008, what is the difference between the Aid flow (current US$) of Colombia and Aid flow (current US$) of Kazakhstan?
Provide a short and direct response. 1.92e+07. In the year 2008, what is the difference between the Aid flow (current US$) in Colombia and Aid flow (current US$) in Tanzania?
Ensure brevity in your answer.  1.79e+07. In the year 2008, what is the difference between the Aid flow (current US$) in Kazakhstan and Aid flow (current US$) in Tanzania?
Your answer should be very brief. -1.37e+06. What is the ratio of the Aid flow (current US$) of China in 2002 to that in 2003?
Give a very brief answer. 1.04. What is the ratio of the Aid flow (current US$) in Colombia in 2002 to that in 2003?
Your response must be concise. 0.88. What is the ratio of the Aid flow (current US$) of Kazakhstan in 2002 to that in 2003?
Your answer should be compact. 1.3. What is the ratio of the Aid flow (current US$) of Tanzania in 2002 to that in 2003?
Offer a terse response. 10.31. What is the ratio of the Aid flow (current US$) of China in 2002 to that in 2004?
Provide a short and direct response. 0.75. What is the ratio of the Aid flow (current US$) in Colombia in 2002 to that in 2004?
Provide a succinct answer. 2.33. What is the ratio of the Aid flow (current US$) of Kazakhstan in 2002 to that in 2004?
Offer a very short reply. 0.81. What is the ratio of the Aid flow (current US$) in Tanzania in 2002 to that in 2004?
Your response must be concise. 0.13. What is the ratio of the Aid flow (current US$) in China in 2002 to that in 2005?
Make the answer very short. 0.62. What is the ratio of the Aid flow (current US$) in Kazakhstan in 2002 to that in 2005?
Your answer should be very brief. 0.88. What is the ratio of the Aid flow (current US$) in Tanzania in 2002 to that in 2005?
Ensure brevity in your answer.  6.44. What is the ratio of the Aid flow (current US$) of China in 2002 to that in 2006?
Provide a short and direct response. 0.54. What is the ratio of the Aid flow (current US$) of Colombia in 2002 to that in 2006?
Ensure brevity in your answer.  0.53. What is the ratio of the Aid flow (current US$) of Kazakhstan in 2002 to that in 2006?
Make the answer very short. 0.76. What is the ratio of the Aid flow (current US$) of Tanzania in 2002 to that in 2006?
Keep it short and to the point. 7.87. What is the ratio of the Aid flow (current US$) of China in 2002 to that in 2007?
Your answer should be compact. 0.58. What is the ratio of the Aid flow (current US$) in Colombia in 2002 to that in 2007?
Provide a succinct answer. 0.38. What is the ratio of the Aid flow (current US$) in Kazakhstan in 2002 to that in 2007?
Keep it short and to the point. 0.64. What is the ratio of the Aid flow (current US$) of Tanzania in 2002 to that in 2007?
Give a very brief answer. 5.4. What is the ratio of the Aid flow (current US$) of China in 2002 to that in 2008?
Offer a very short reply. 0.37. What is the ratio of the Aid flow (current US$) in Colombia in 2002 to that in 2008?
Your response must be concise. 0.57. What is the ratio of the Aid flow (current US$) of Kazakhstan in 2002 to that in 2008?
Give a very brief answer. 0.66. What is the ratio of the Aid flow (current US$) of Tanzania in 2002 to that in 2008?
Offer a very short reply. 3.34. What is the ratio of the Aid flow (current US$) in China in 2003 to that in 2004?
Ensure brevity in your answer.  0.72. What is the ratio of the Aid flow (current US$) in Colombia in 2003 to that in 2004?
Your answer should be compact. 2.66. What is the ratio of the Aid flow (current US$) of Kazakhstan in 2003 to that in 2004?
Provide a succinct answer. 0.62. What is the ratio of the Aid flow (current US$) in Tanzania in 2003 to that in 2004?
Provide a short and direct response. 0.01. What is the ratio of the Aid flow (current US$) in China in 2003 to that in 2005?
Make the answer very short. 0.59. What is the ratio of the Aid flow (current US$) of Kazakhstan in 2003 to that in 2005?
Give a very brief answer. 0.68. What is the ratio of the Aid flow (current US$) of Tanzania in 2003 to that in 2005?
Keep it short and to the point. 0.62. What is the ratio of the Aid flow (current US$) in China in 2003 to that in 2006?
Your answer should be very brief. 0.52. What is the ratio of the Aid flow (current US$) of Colombia in 2003 to that in 2006?
Your response must be concise. 0.61. What is the ratio of the Aid flow (current US$) of Kazakhstan in 2003 to that in 2006?
Offer a very short reply. 0.59. What is the ratio of the Aid flow (current US$) of Tanzania in 2003 to that in 2006?
Your answer should be compact. 0.76. What is the ratio of the Aid flow (current US$) of China in 2003 to that in 2007?
Give a very brief answer. 0.56. What is the ratio of the Aid flow (current US$) in Colombia in 2003 to that in 2007?
Provide a succinct answer. 0.43. What is the ratio of the Aid flow (current US$) in Kazakhstan in 2003 to that in 2007?
Make the answer very short. 0.49. What is the ratio of the Aid flow (current US$) in Tanzania in 2003 to that in 2007?
Your response must be concise. 0.52. What is the ratio of the Aid flow (current US$) of China in 2003 to that in 2008?
Keep it short and to the point. 0.36. What is the ratio of the Aid flow (current US$) of Colombia in 2003 to that in 2008?
Your answer should be very brief. 0.65. What is the ratio of the Aid flow (current US$) in Kazakhstan in 2003 to that in 2008?
Offer a very short reply. 0.51. What is the ratio of the Aid flow (current US$) of Tanzania in 2003 to that in 2008?
Offer a terse response. 0.32. What is the ratio of the Aid flow (current US$) of China in 2004 to that in 2005?
Offer a terse response. 0.82. What is the ratio of the Aid flow (current US$) in Kazakhstan in 2004 to that in 2005?
Ensure brevity in your answer.  1.09. What is the ratio of the Aid flow (current US$) in Tanzania in 2004 to that in 2005?
Make the answer very short. 48.37. What is the ratio of the Aid flow (current US$) in China in 2004 to that in 2006?
Offer a terse response. 0.72. What is the ratio of the Aid flow (current US$) in Colombia in 2004 to that in 2006?
Give a very brief answer. 0.23. What is the ratio of the Aid flow (current US$) in Kazakhstan in 2004 to that in 2006?
Provide a succinct answer. 0.94. What is the ratio of the Aid flow (current US$) of Tanzania in 2004 to that in 2006?
Provide a short and direct response. 59.09. What is the ratio of the Aid flow (current US$) in China in 2004 to that in 2007?
Your answer should be compact. 0.78. What is the ratio of the Aid flow (current US$) of Colombia in 2004 to that in 2007?
Provide a succinct answer. 0.16. What is the ratio of the Aid flow (current US$) of Kazakhstan in 2004 to that in 2007?
Ensure brevity in your answer.  0.79. What is the ratio of the Aid flow (current US$) of Tanzania in 2004 to that in 2007?
Provide a succinct answer. 40.52. What is the ratio of the Aid flow (current US$) in China in 2004 to that in 2008?
Keep it short and to the point. 0.5. What is the ratio of the Aid flow (current US$) in Colombia in 2004 to that in 2008?
Provide a short and direct response. 0.25. What is the ratio of the Aid flow (current US$) in Kazakhstan in 2004 to that in 2008?
Your response must be concise. 0.82. What is the ratio of the Aid flow (current US$) in Tanzania in 2004 to that in 2008?
Ensure brevity in your answer.  25.09. What is the ratio of the Aid flow (current US$) of China in 2005 to that in 2006?
Ensure brevity in your answer.  0.88. What is the ratio of the Aid flow (current US$) of Kazakhstan in 2005 to that in 2006?
Make the answer very short. 0.87. What is the ratio of the Aid flow (current US$) of Tanzania in 2005 to that in 2006?
Ensure brevity in your answer.  1.22. What is the ratio of the Aid flow (current US$) in China in 2005 to that in 2007?
Your answer should be compact. 0.95. What is the ratio of the Aid flow (current US$) in Kazakhstan in 2005 to that in 2007?
Provide a short and direct response. 0.73. What is the ratio of the Aid flow (current US$) in Tanzania in 2005 to that in 2007?
Provide a short and direct response. 0.84. What is the ratio of the Aid flow (current US$) in China in 2005 to that in 2008?
Ensure brevity in your answer.  0.6. What is the ratio of the Aid flow (current US$) of Kazakhstan in 2005 to that in 2008?
Make the answer very short. 0.75. What is the ratio of the Aid flow (current US$) in Tanzania in 2005 to that in 2008?
Ensure brevity in your answer.  0.52. What is the ratio of the Aid flow (current US$) in China in 2006 to that in 2007?
Your answer should be compact. 1.08. What is the ratio of the Aid flow (current US$) in Colombia in 2006 to that in 2007?
Your response must be concise. 0.71. What is the ratio of the Aid flow (current US$) in Kazakhstan in 2006 to that in 2007?
Your answer should be very brief. 0.84. What is the ratio of the Aid flow (current US$) in Tanzania in 2006 to that in 2007?
Give a very brief answer. 0.69. What is the ratio of the Aid flow (current US$) of China in 2006 to that in 2008?
Your answer should be very brief. 0.69. What is the ratio of the Aid flow (current US$) in Colombia in 2006 to that in 2008?
Your response must be concise. 1.08. What is the ratio of the Aid flow (current US$) in Kazakhstan in 2006 to that in 2008?
Your answer should be compact. 0.87. What is the ratio of the Aid flow (current US$) in Tanzania in 2006 to that in 2008?
Make the answer very short. 0.42. What is the ratio of the Aid flow (current US$) of China in 2007 to that in 2008?
Your response must be concise. 0.64. What is the ratio of the Aid flow (current US$) in Colombia in 2007 to that in 2008?
Keep it short and to the point. 1.52. What is the ratio of the Aid flow (current US$) of Kazakhstan in 2007 to that in 2008?
Give a very brief answer. 1.04. What is the ratio of the Aid flow (current US$) of Tanzania in 2007 to that in 2008?
Your answer should be compact. 0.62. What is the difference between the highest and the second highest Aid flow (current US$) of China?
Make the answer very short. 6.47e+07. What is the difference between the highest and the second highest Aid flow (current US$) in Colombia?
Provide a succinct answer. 1.01e+07. What is the difference between the highest and the second highest Aid flow (current US$) of Kazakhstan?
Ensure brevity in your answer.  1.30e+05. What is the difference between the highest and the second highest Aid flow (current US$) of Tanzania?
Keep it short and to the point. 1.04e+08. What is the difference between the highest and the lowest Aid flow (current US$) of China?
Offer a very short reply. 1.33e+08. What is the difference between the highest and the lowest Aid flow (current US$) in Colombia?
Keep it short and to the point. 3.44e+07. What is the difference between the highest and the lowest Aid flow (current US$) in Kazakhstan?
Your response must be concise. 1.80e+06. What is the difference between the highest and the lowest Aid flow (current US$) in Tanzania?
Provide a short and direct response. 1.18e+08. 